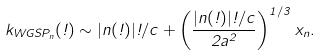<formula> <loc_0><loc_0><loc_500><loc_500>k _ { W G S P _ { n } } ( \omega ) \sim | n ( \omega ) | \omega / c + \left ( \frac { | n ( \omega ) | \omega / c } { 2 a ^ { 2 } } \right ) ^ { 1 / 3 } x _ { n } .</formula> 